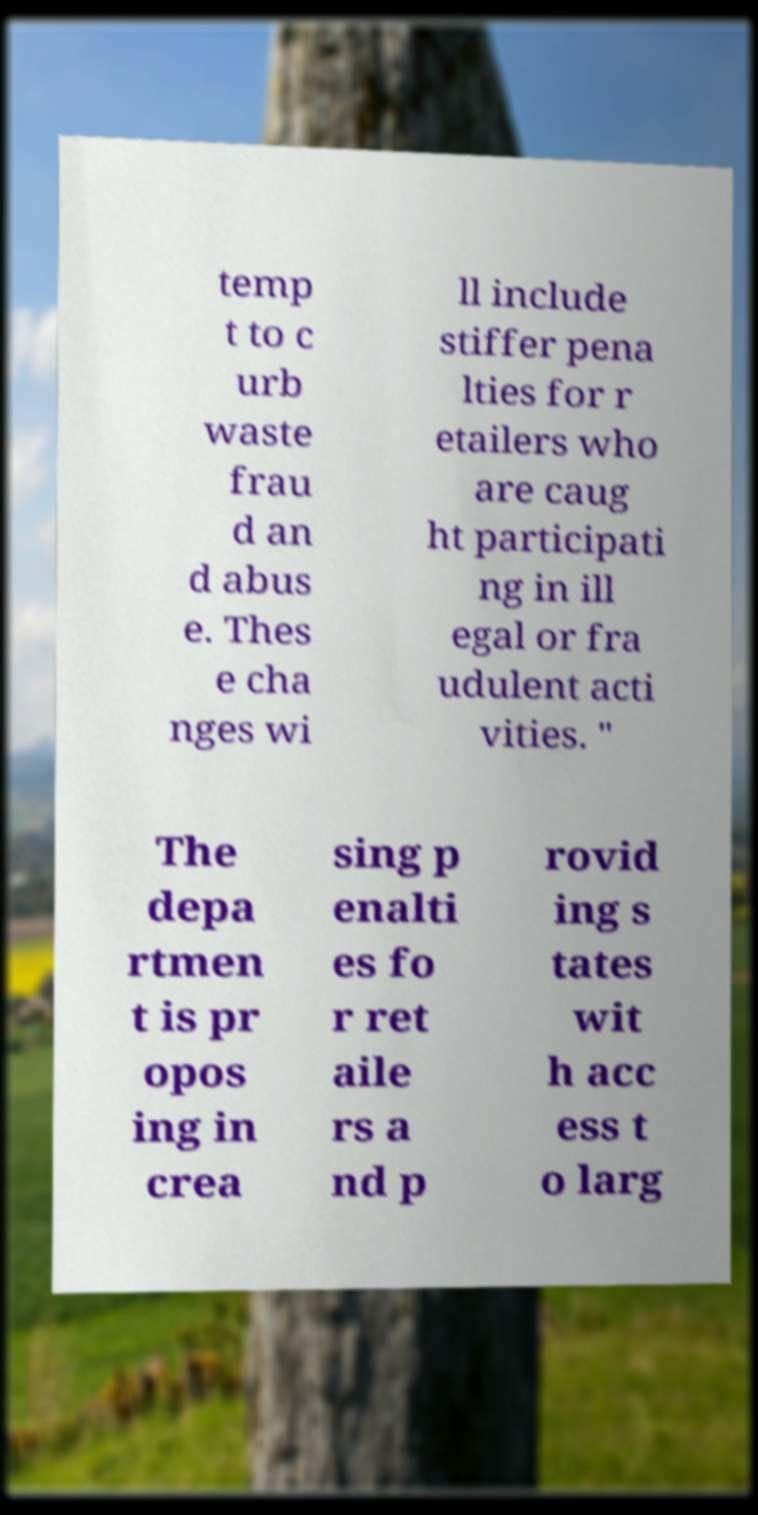What messages or text are displayed in this image? I need them in a readable, typed format. temp t to c urb waste frau d an d abus e. Thes e cha nges wi ll include stiffer pena lties for r etailers who are caug ht participati ng in ill egal or fra udulent acti vities. " The depa rtmen t is pr opos ing in crea sing p enalti es fo r ret aile rs a nd p rovid ing s tates wit h acc ess t o larg 